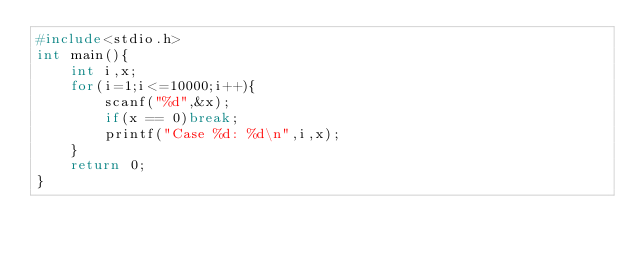<code> <loc_0><loc_0><loc_500><loc_500><_C_>#include<stdio.h>
int main(){
	int i,x;
	for(i=1;i<=10000;i++){
		scanf("%d",&x);
		if(x == 0)break;
		printf("Case %d: %d\n",i,x);
	}
	return 0;
}</code> 